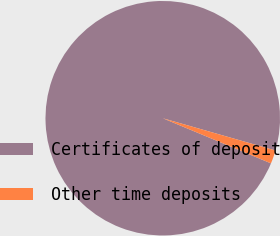Convert chart to OTSL. <chart><loc_0><loc_0><loc_500><loc_500><pie_chart><fcel>Certificates of deposit<fcel>Other time deposits<nl><fcel>98.15%<fcel>1.85%<nl></chart> 